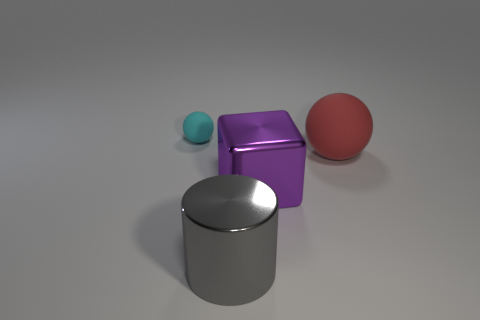Add 3 brown matte objects. How many objects exist? 7 Subtract 1 spheres. How many spheres are left? 1 Add 3 tiny cyan rubber spheres. How many tiny cyan rubber spheres are left? 4 Add 4 green balls. How many green balls exist? 4 Subtract 0 brown cylinders. How many objects are left? 4 Subtract all cubes. How many objects are left? 3 Subtract all brown cubes. Subtract all green cylinders. How many cubes are left? 1 Subtract all small yellow cubes. Subtract all large purple cubes. How many objects are left? 3 